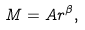Convert formula to latex. <formula><loc_0><loc_0><loc_500><loc_500>M = A r ^ { \beta } ,</formula> 